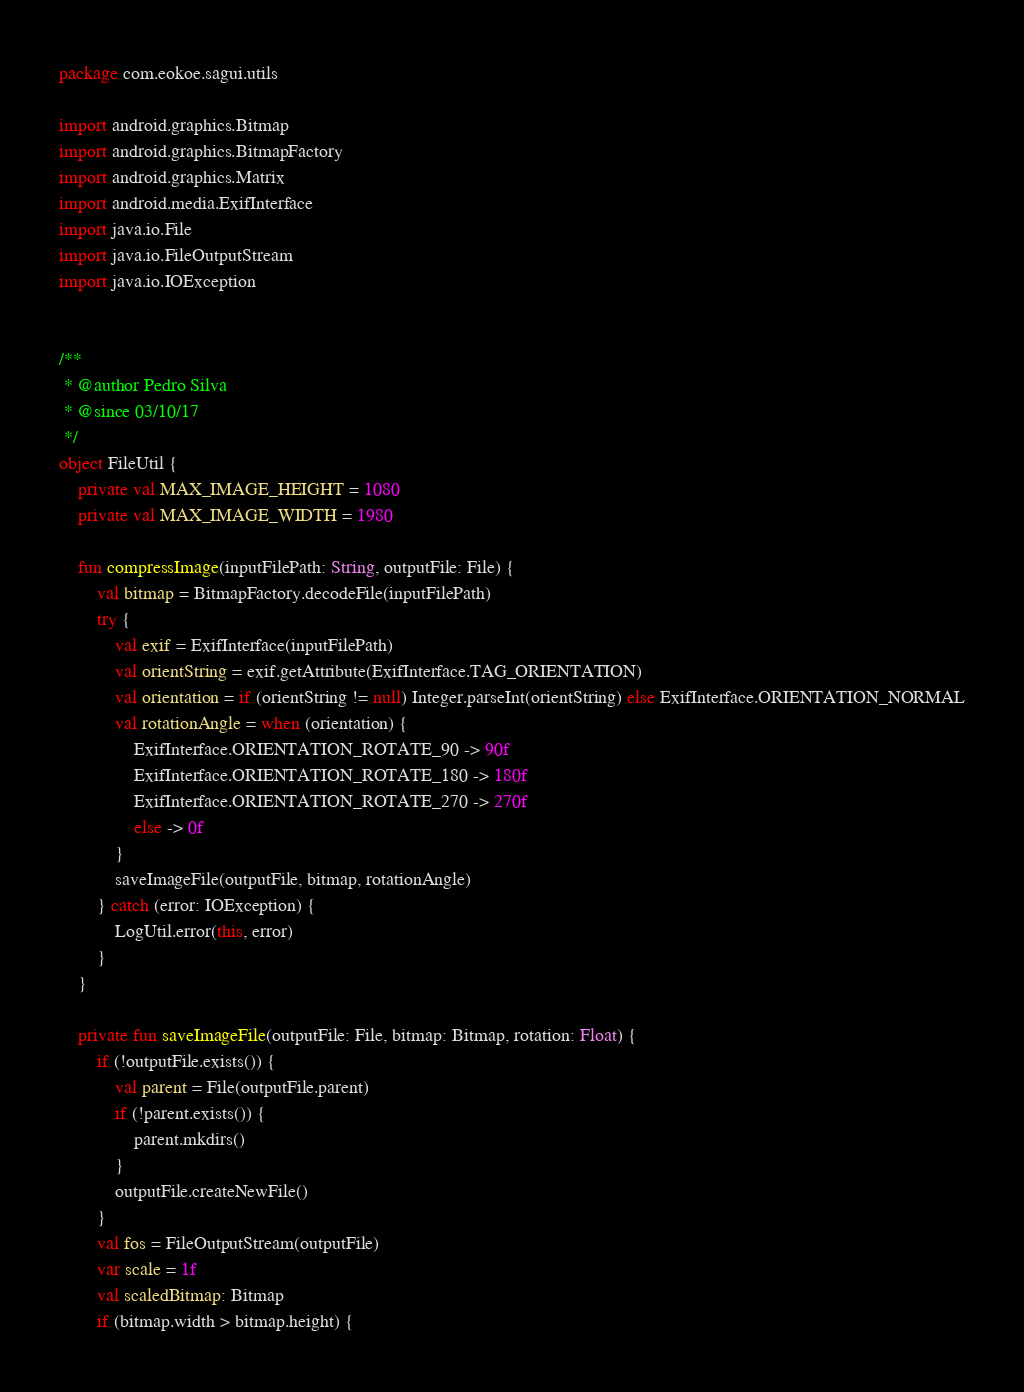Convert code to text. <code><loc_0><loc_0><loc_500><loc_500><_Kotlin_>package com.eokoe.sagui.utils

import android.graphics.Bitmap
import android.graphics.BitmapFactory
import android.graphics.Matrix
import android.media.ExifInterface
import java.io.File
import java.io.FileOutputStream
import java.io.IOException


/**
 * @author Pedro Silva
 * @since 03/10/17
 */
object FileUtil {
    private val MAX_IMAGE_HEIGHT = 1080
    private val MAX_IMAGE_WIDTH = 1980

    fun compressImage(inputFilePath: String, outputFile: File) {
        val bitmap = BitmapFactory.decodeFile(inputFilePath)
        try {
            val exif = ExifInterface(inputFilePath)
            val orientString = exif.getAttribute(ExifInterface.TAG_ORIENTATION)
            val orientation = if (orientString != null) Integer.parseInt(orientString) else ExifInterface.ORIENTATION_NORMAL
            val rotationAngle = when (orientation) {
                ExifInterface.ORIENTATION_ROTATE_90 -> 90f
                ExifInterface.ORIENTATION_ROTATE_180 -> 180f
                ExifInterface.ORIENTATION_ROTATE_270 -> 270f
                else -> 0f
            }
            saveImageFile(outputFile, bitmap, rotationAngle)
        } catch (error: IOException) {
            LogUtil.error(this, error)
        }
    }

    private fun saveImageFile(outputFile: File, bitmap: Bitmap, rotation: Float) {
        if (!outputFile.exists()) {
            val parent = File(outputFile.parent)
            if (!parent.exists()) {
                parent.mkdirs()
            }
            outputFile.createNewFile()
        }
        val fos = FileOutputStream(outputFile)
        var scale = 1f
        val scaledBitmap: Bitmap
        if (bitmap.width > bitmap.height) {</code> 